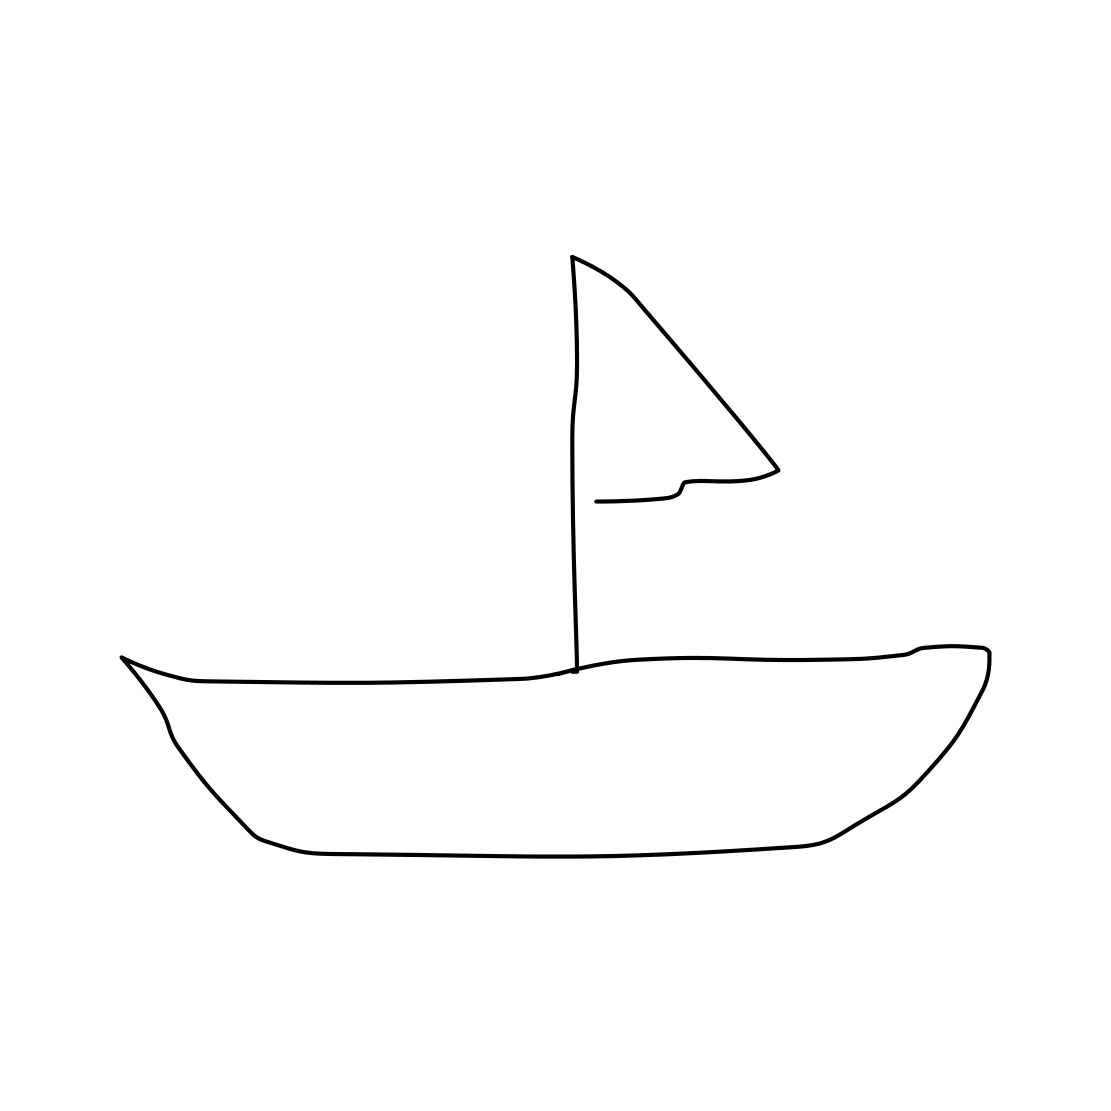Is there a sketchy cow in the picture? No, the image does not depict a cow of any kind. It is actually a minimalist line drawing of a sailboat, featuring just the hull and a single sail. 